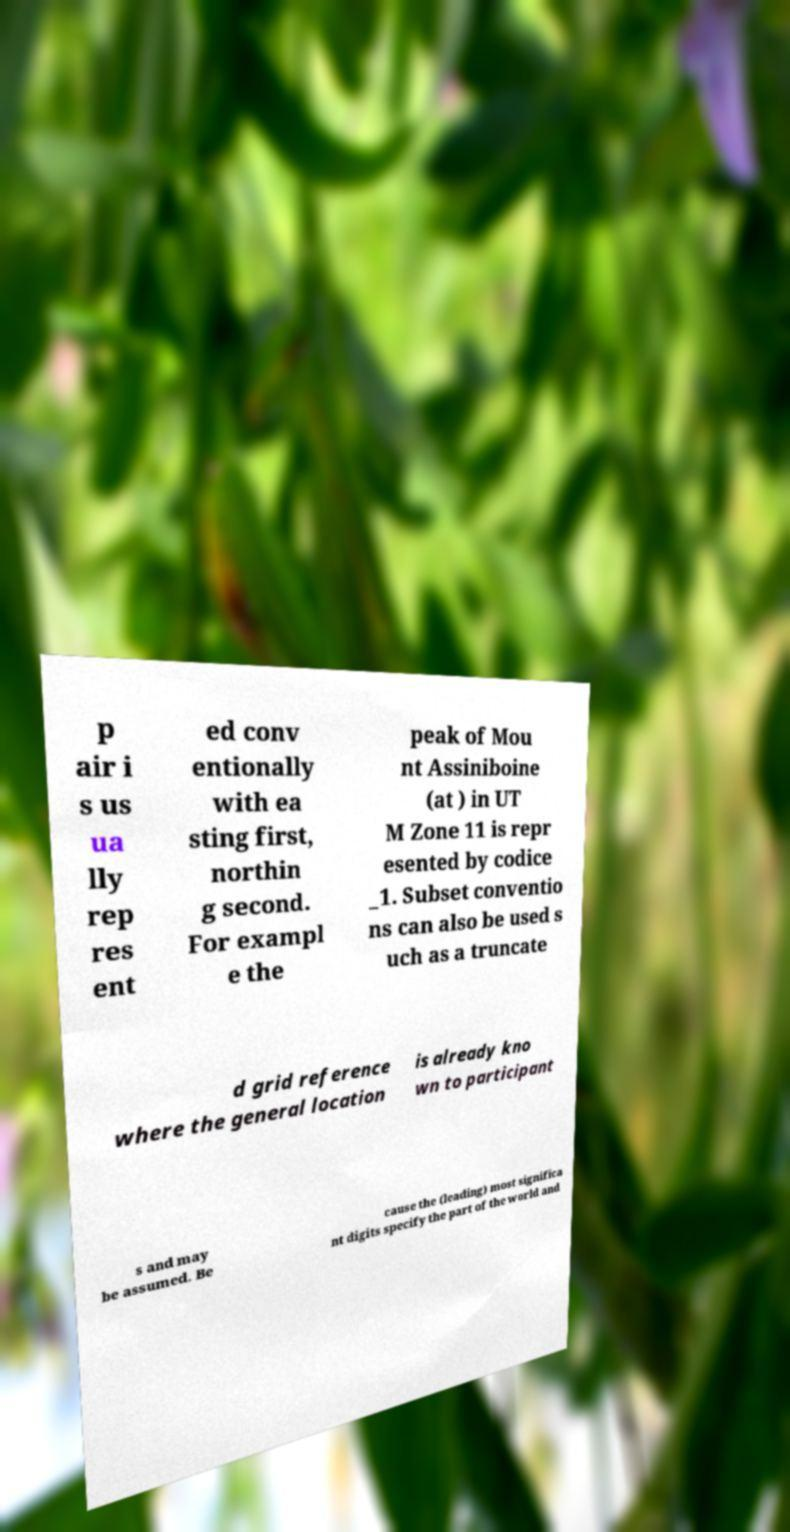Could you assist in decoding the text presented in this image and type it out clearly? p air i s us ua lly rep res ent ed conv entionally with ea sting first, northin g second. For exampl e the peak of Mou nt Assiniboine (at ) in UT M Zone 11 is repr esented by codice _1. Subset conventio ns can also be used s uch as a truncate d grid reference where the general location is already kno wn to participant s and may be assumed. Be cause the (leading) most significa nt digits specify the part of the world and 